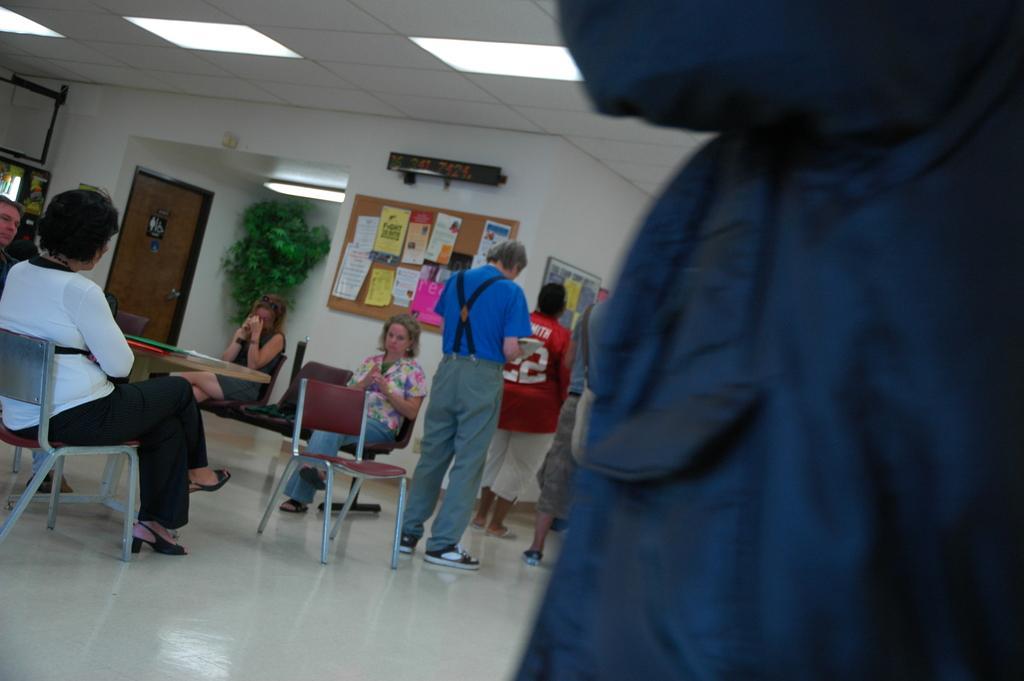In one or two sentences, can you explain what this image depicts? in this picture we can see a room where some people sitting on the chairs in front of the table and the other standing in the queue and to the wall there are some notice boards and a plant. 